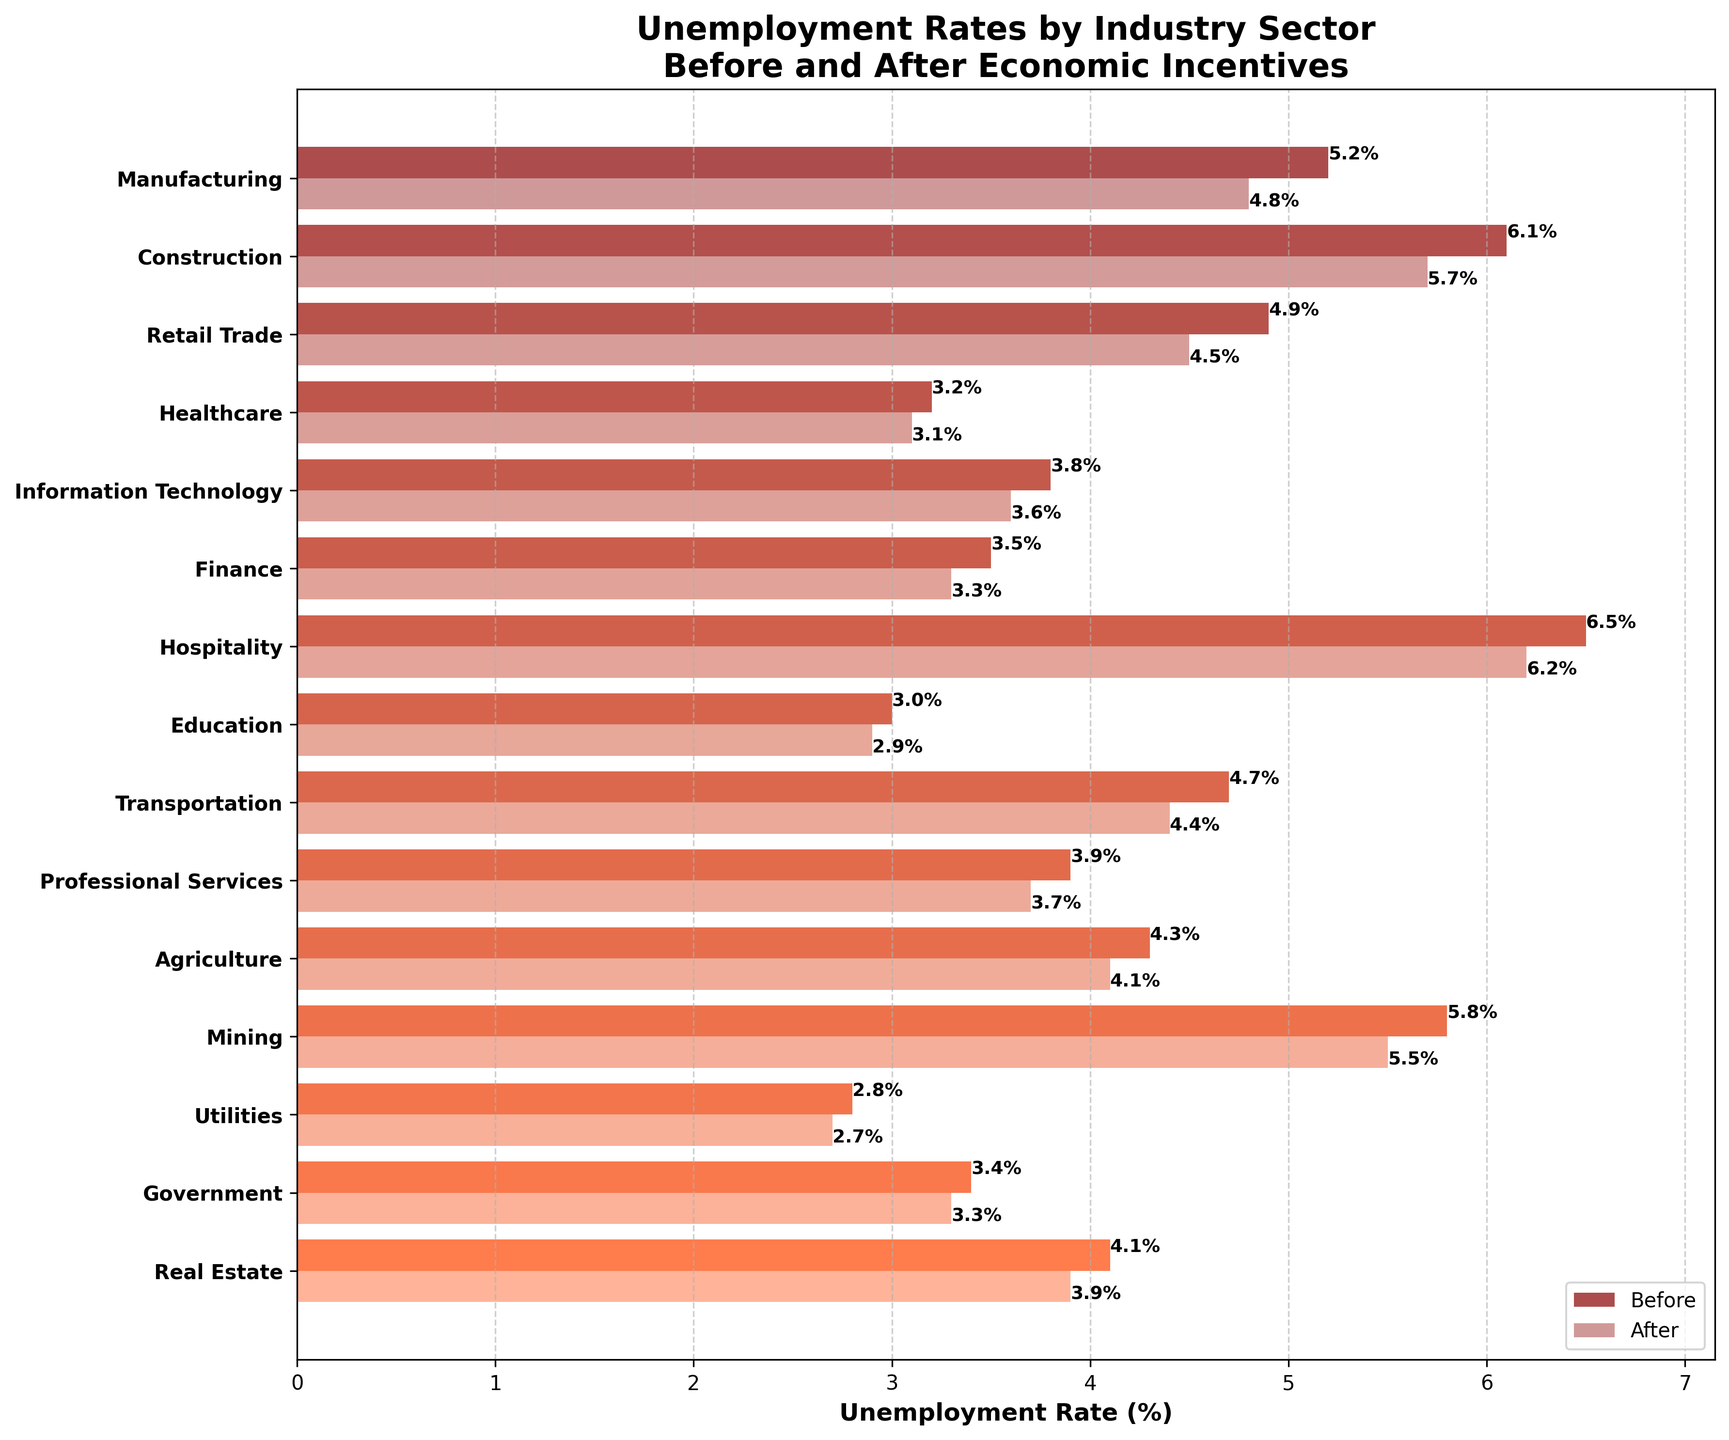What's the title of the figure? The title is located at the top of the figure. It summarizes the content of the chart.
Answer: Unemployment Rates by Industry Sector Before and After Economic Incentives Which industry has the lowest unemployment rate after the economic incentives? The 'after' bars represent the unemployment rates after the implementation of economic incentives. Locate the shortest bar among them.
Answer: Utilities What is the difference in the unemployment rate for the Construction industry before and after the economic incentives? Find the 'before' and 'after' values for the Construction industry, then subtract the 'after' value from the 'before' value.
Answer: \(6.1 - 5.7 = 0.4\%\) Which industry shows the largest absolute decrease in unemployment rate after the economic incentives? Calculate the difference between 'before' and 'after' for each industry and identify the one with the largest decrease.
Answer: Construction How does the unemployment rate in the Information Technology sector after economic incentives compare to that in the Retail Trade sector before incentives? Compare the 'after' value for Information Technology with the 'before' value for Retail Trade. Observe which is higher.
Answer: 3.6% is lower than 4.9% What is the sum of the unemployment rates for the Healthcare and Finance sectors before the implementation of economic incentives? Combine the 'before' values for Healthcare and Finance by adding them together.
Answer: \(3.2 + 3.5 = 6.7\%\) In which sector is the change in unemployment rate the smallest after the economic incentives? Calculate the changes in unemployment rates for all sectors and identify the smallest change.
Answer: Utilities Which sector had an unemployment rate above 5% both before and after the economic incentives? Look for bars (both 'before' and 'after') that are above 5% and identify the corresponding industry.
Answer: Hospitality 